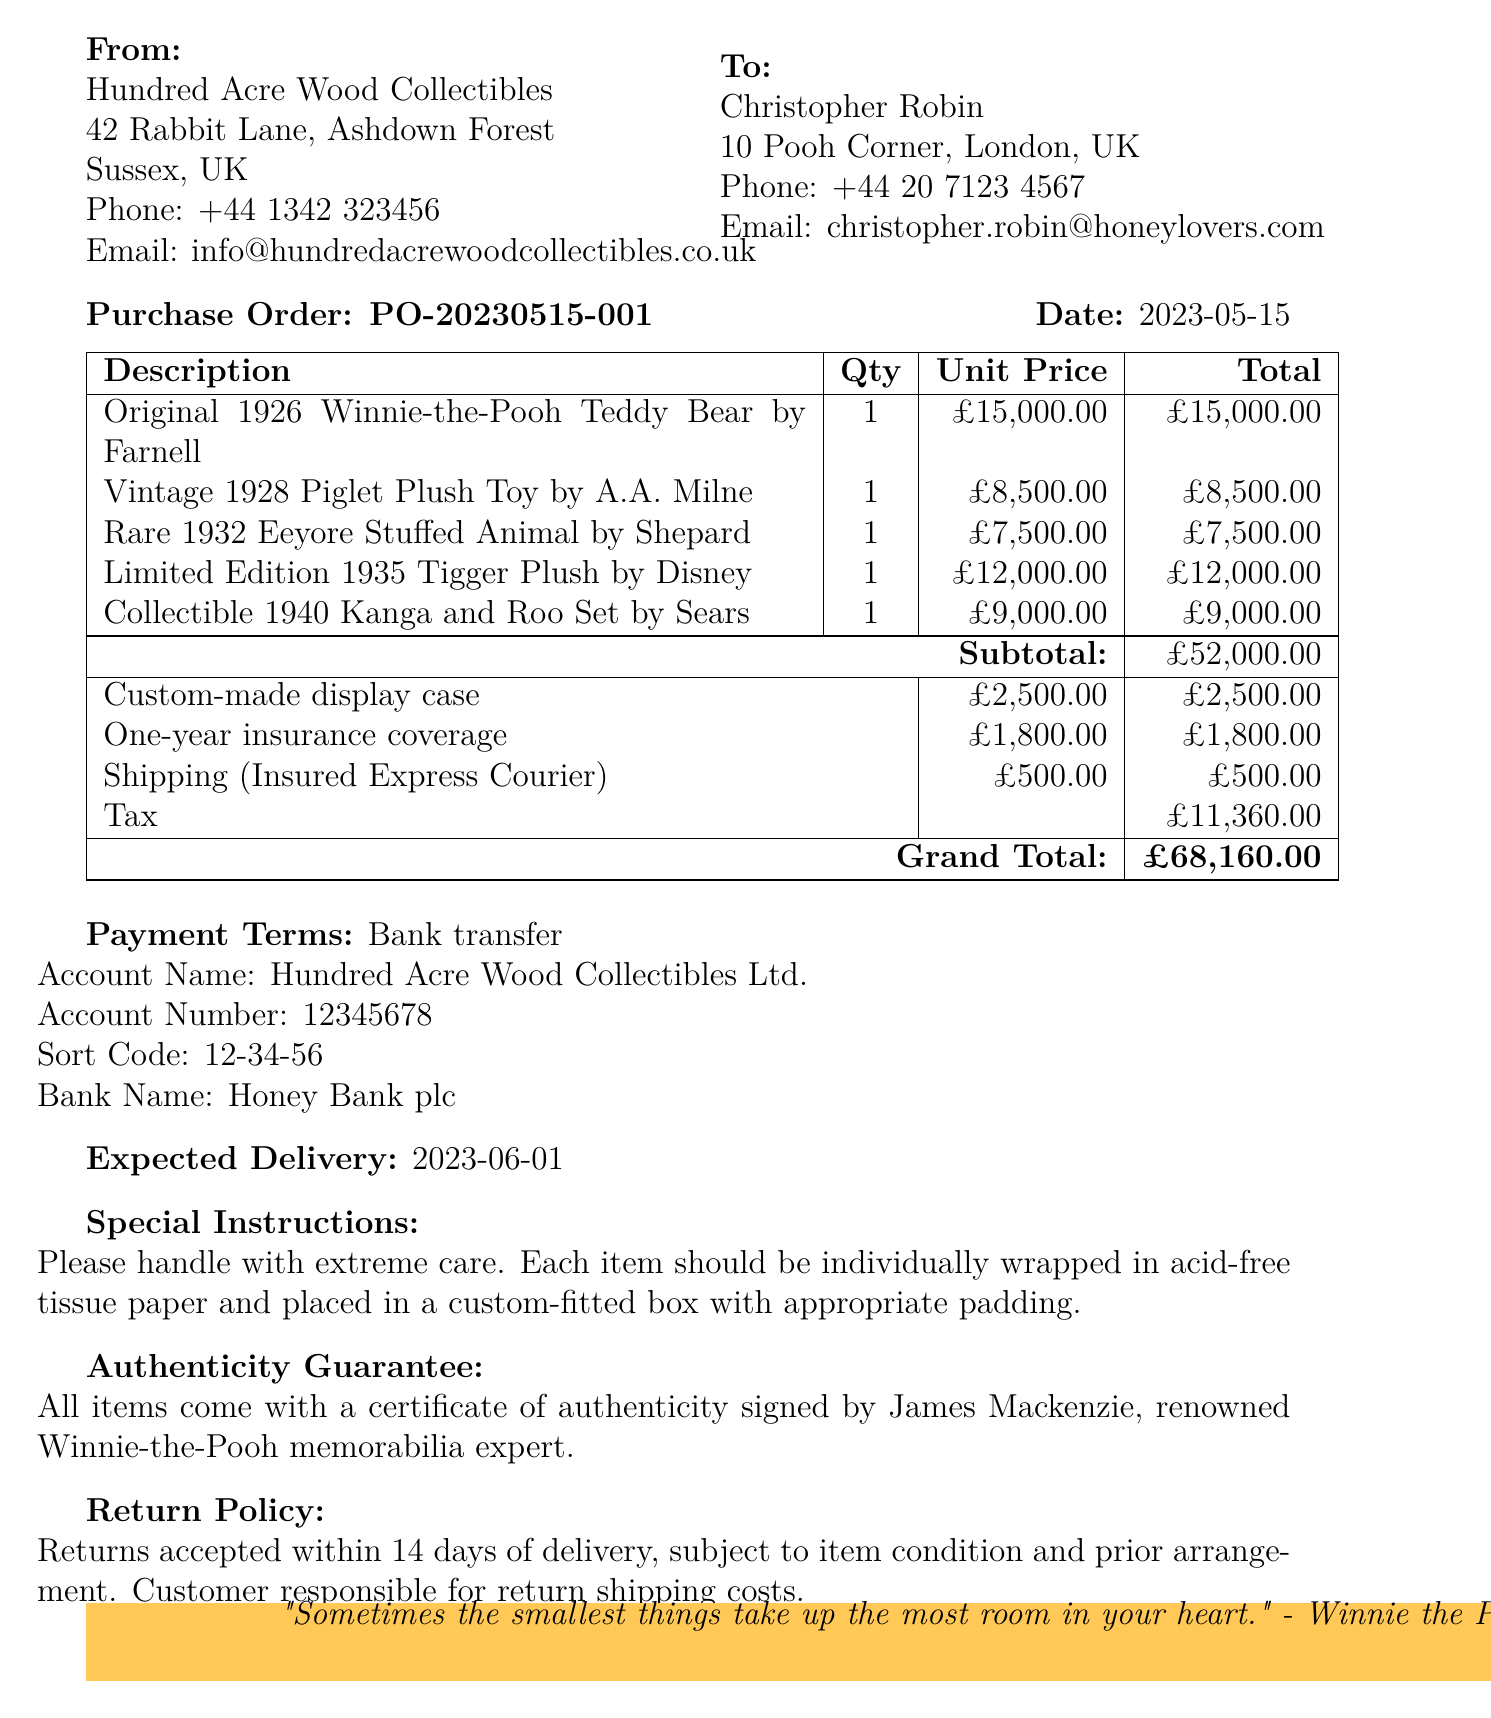What is the total amount due? The grand total is provided at the end of the document, which includes subtotal, additional services, shipping, and tax.
Answer: £68,160.00 Who is the order addressed to? The document specifies the customer's details, including their name and address, directly under "To:".
Answer: Christopher Robin What is the expected delivery date? The expected delivery date is noted in the document, indicating when the items will arrive.
Answer: 2023-06-01 How many items are listed in the purchase order? The number of items can be counted from the list provided in the document.
Answer: 5 What payment method is being used? The document outlines the payment terms and specifically mentions how the payment will be made.
Answer: Bank transfer What is the return policy duration? The document states the return policy period after delivery for returns, highlighting the customer's responsibilities.
Answer: 14 days Who signed the authenticity guarantee? The certificate of authenticity mentioned in the document is signed by a specific individual known for expertise in Winnie-the-Pooh memorabilia.
Answer: James Mackenzie What additional service has a price of £2,500.00? The document details additional services offered, including a custom-made display case.
Answer: Custom-made display case What shipping method will be used for the order? Details about how items will be shipped are specified in the shipping section of the document.
Answer: Insured Express Courier 